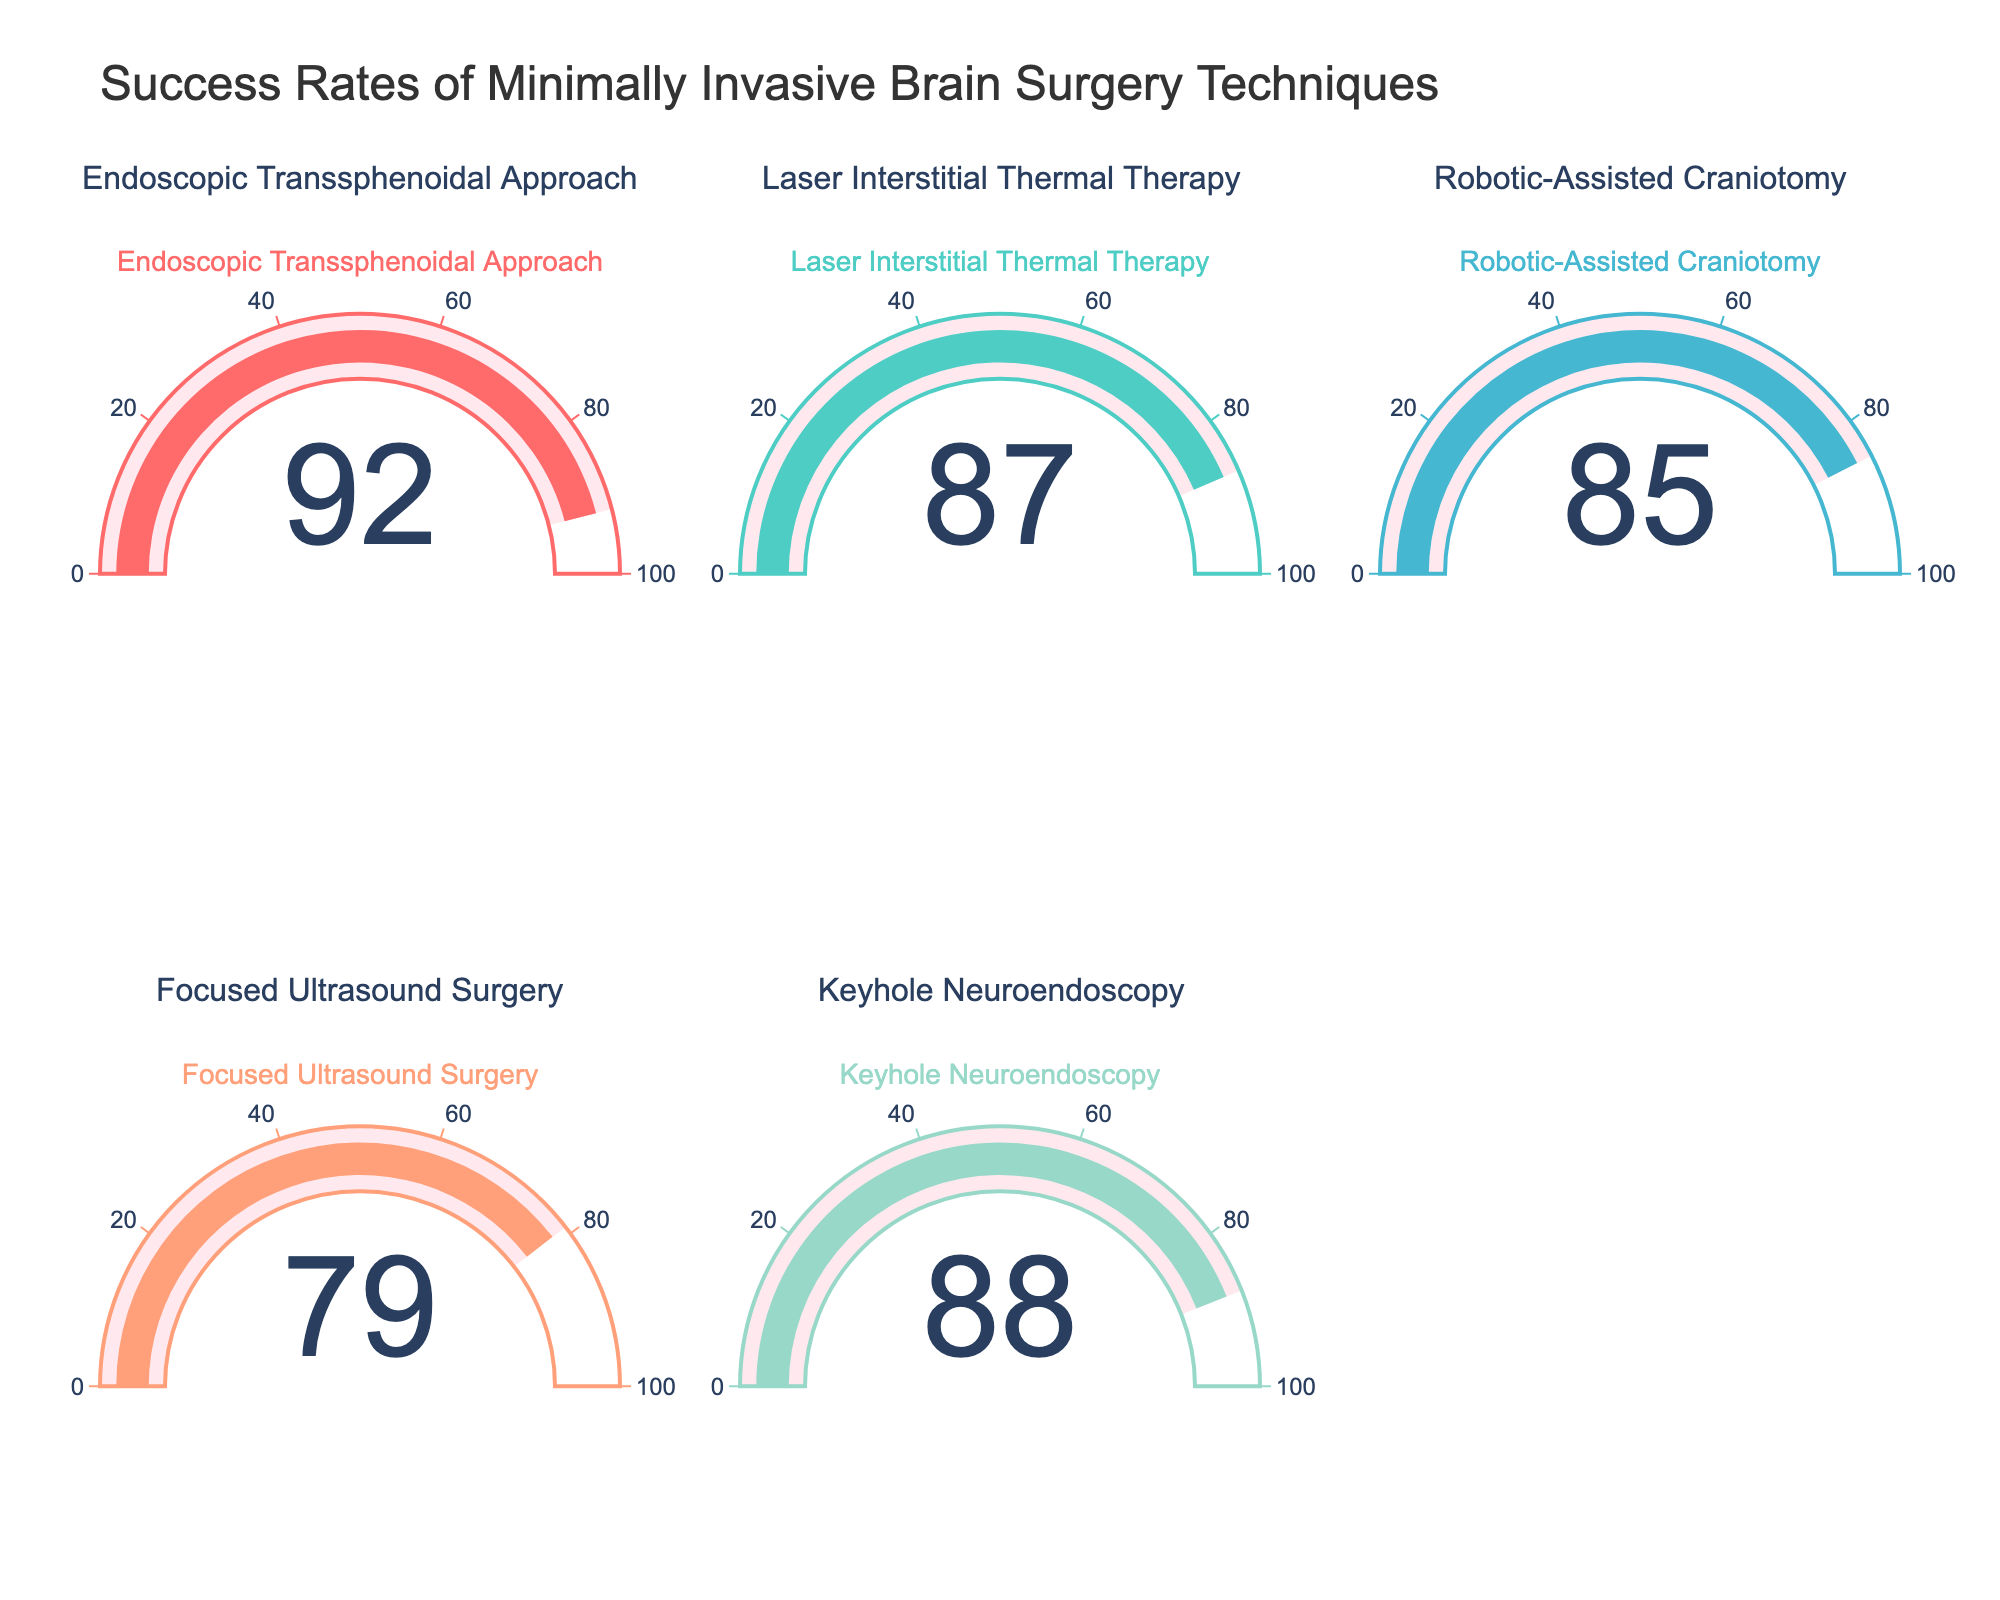what is the title of the chart? The title of the chart can be found at the top of the figure and it describes the general subject of the plot. It reads "Success Rates of Minimally Invasive Brain Surgery Techniques"
Answer: Success Rates of Minimally Invasive Brain Surgery Techniques how many different brain surgery techniques are presented in the figure? By counting the separate gauge charts, each labeled with a different surgery technique, we see that there are five techniques shown
Answer: five which brain surgery technique has the highest success rate? By comparing the success rates indicated by the numbers on each gauge, the highest value is 92 for the Endoscopic Transsphenoidal Approach
Answer: Endoscopic Transsphenoidal Approach what's the success rate for Keyhole Neuroendoscopy? Locate the gauge chart with the title “Keyhole Neuroendoscopy” and read the value indicated, which is 88
Answer: 88 how much higher is the success rate of Laser Interstitial Thermal Therapy compared to Focused Ultrasound Surgery? Subtract the success rate of Focused Ultrasound Surgery (79) from Laser Interstitial Thermal Therapy (87). This gives us 87 - 79 = 8
Answer: 8 what is the average success rate of all the brain surgery techniques presented? Add up the success rates[92, 87, 85, 79, 88] and then divide by the number of techniques, which is 5. So, (92 + 87 + 85 + 79 + 88)/5 = 431/5 = 86.2
Answer: 86.2 which brain surgery technique has the lowest success rate? By comparing the success rates indicated on each gauge, the lowest value is 79 for Focused Ultrasound Surgery
Answer: Focused Ultrasound Surgery how many techniques have a success rate above 85? Count how many of the indicated success rates are greater than 85: Endoscopic Transsphenoidal Approach (92), Laser Interstitial Thermal Therapy (87), Keyhole Neuroendoscopy (88). This gives us 3 techniques
Answer: 3 is the success rate of Robotic-Assisted Craniotomy higher than the average success rate of all techniques? The average success rate is 86.2, and the success rate for Robotic-Assisted Craniotomy is 85. Since 85 < 86.2, the answer is no
Answer: no 